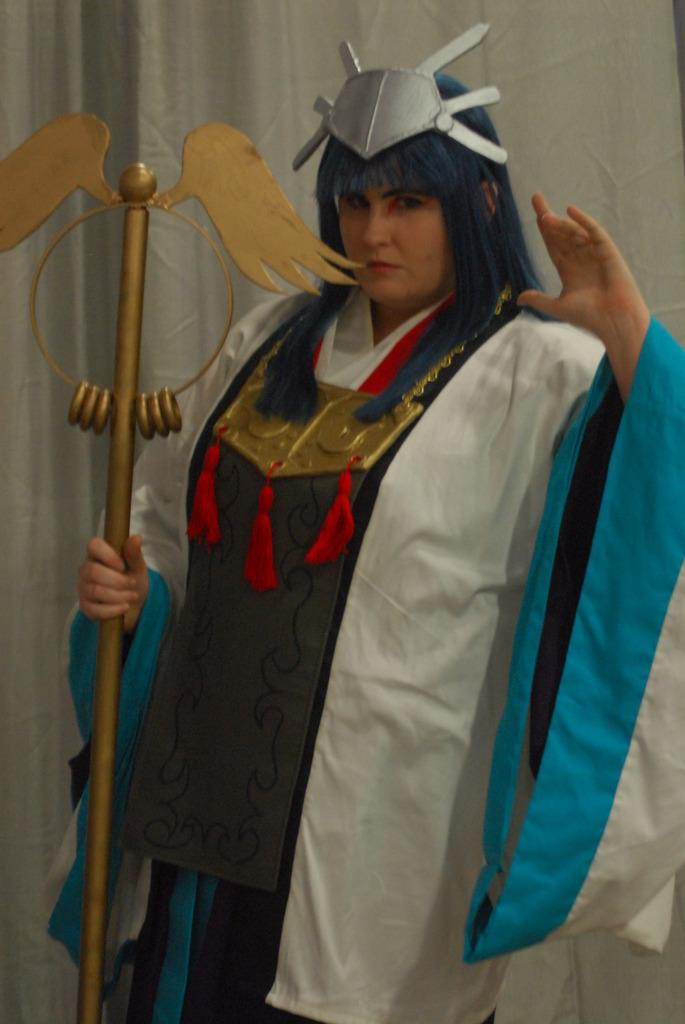Who is the main subject in the image? There is a woman in the image. Where is the woman positioned in the image? The woman is standing in the center of the image. What is the woman holding in her hand? The woman is holding a stick in her hand. What can be seen in the background of the image? There is a white color curtain in the background of the image. Are there any nets visible in the image? No, there are no nets present in the image. Can you see any fangs on the woman in the image? No, there are no fangs visible on the woman in the image. 